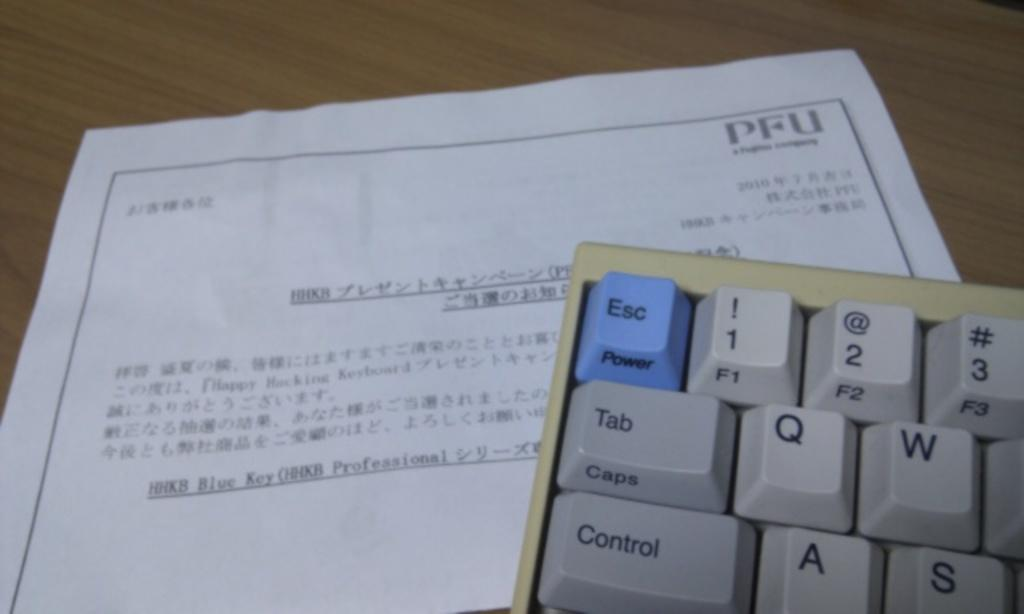<image>
Write a terse but informative summary of the picture. The tope left ten keys of a keyboard rest on a sheet of paper that has chinese writing. 